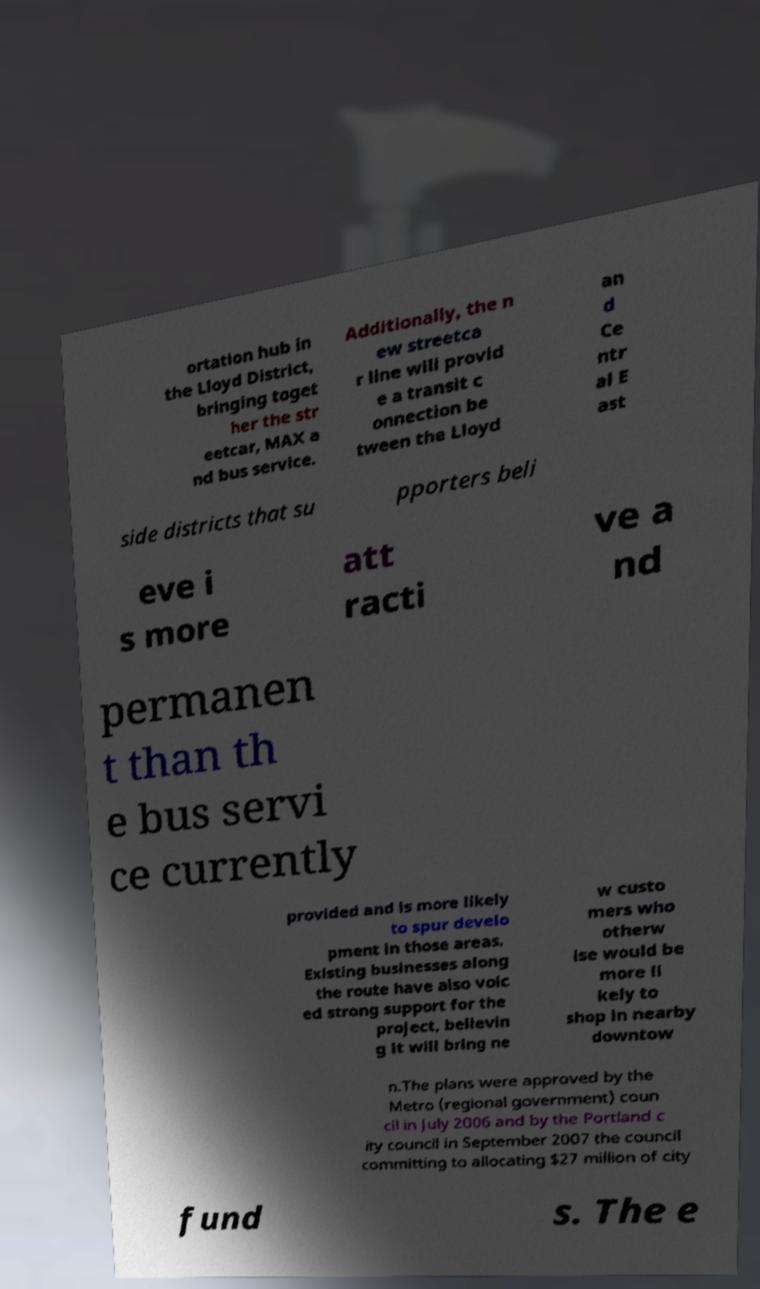For documentation purposes, I need the text within this image transcribed. Could you provide that? ortation hub in the Lloyd District, bringing toget her the str eetcar, MAX a nd bus service. Additionally, the n ew streetca r line will provid e a transit c onnection be tween the Lloyd an d Ce ntr al E ast side districts that su pporters beli eve i s more att racti ve a nd permanen t than th e bus servi ce currently provided and is more likely to spur develo pment in those areas. Existing businesses along the route have also voic ed strong support for the project, believin g it will bring ne w custo mers who otherw ise would be more li kely to shop in nearby downtow n.The plans were approved by the Metro (regional government) coun cil in July 2006 and by the Portland c ity council in September 2007 the council committing to allocating $27 million of city fund s. The e 